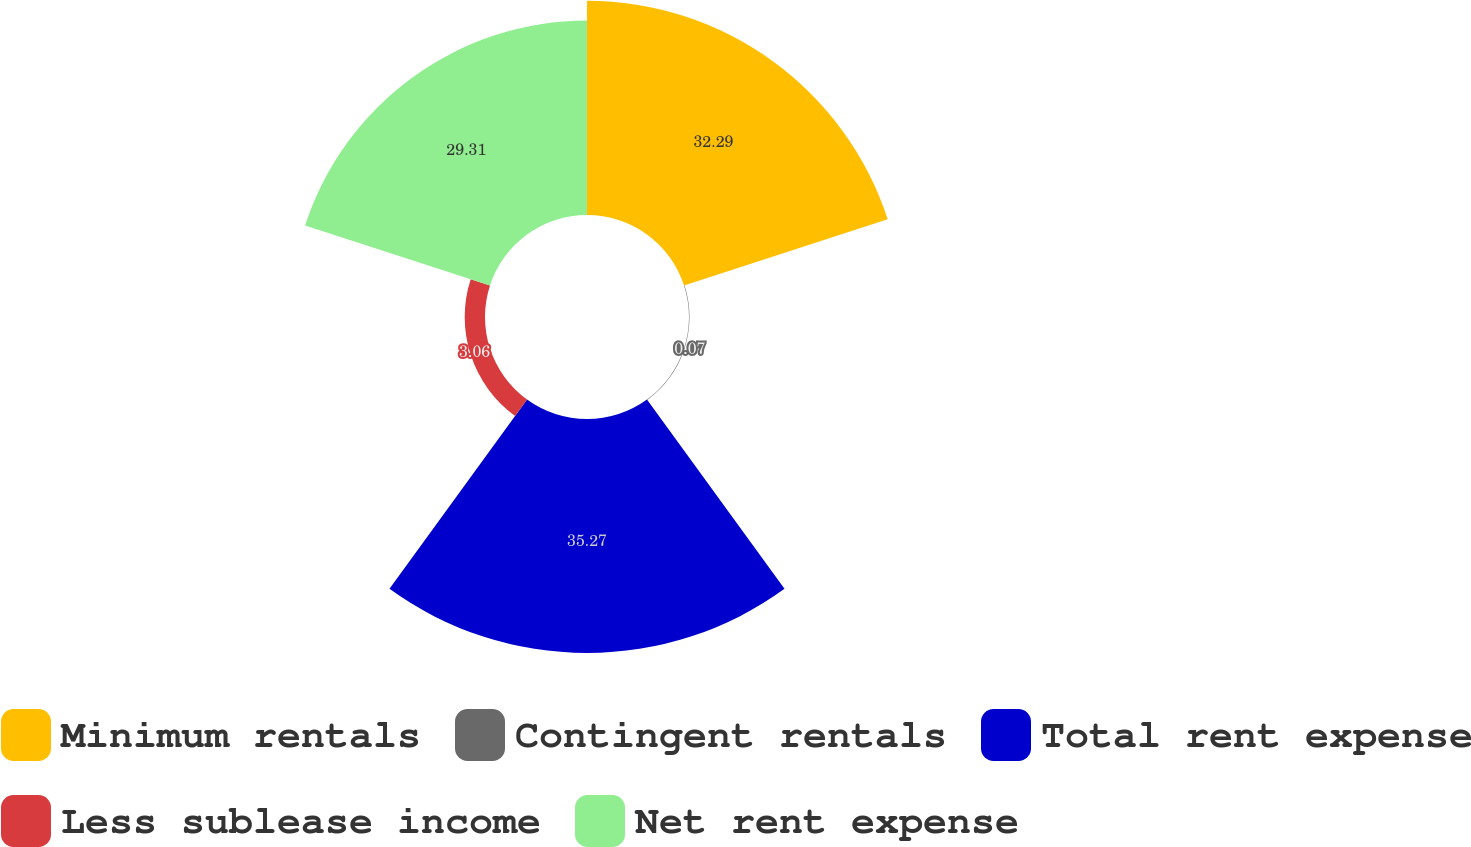<chart> <loc_0><loc_0><loc_500><loc_500><pie_chart><fcel>Minimum rentals<fcel>Contingent rentals<fcel>Total rent expense<fcel>Less sublease income<fcel>Net rent expense<nl><fcel>32.29%<fcel>0.07%<fcel>35.28%<fcel>3.06%<fcel>29.31%<nl></chart> 